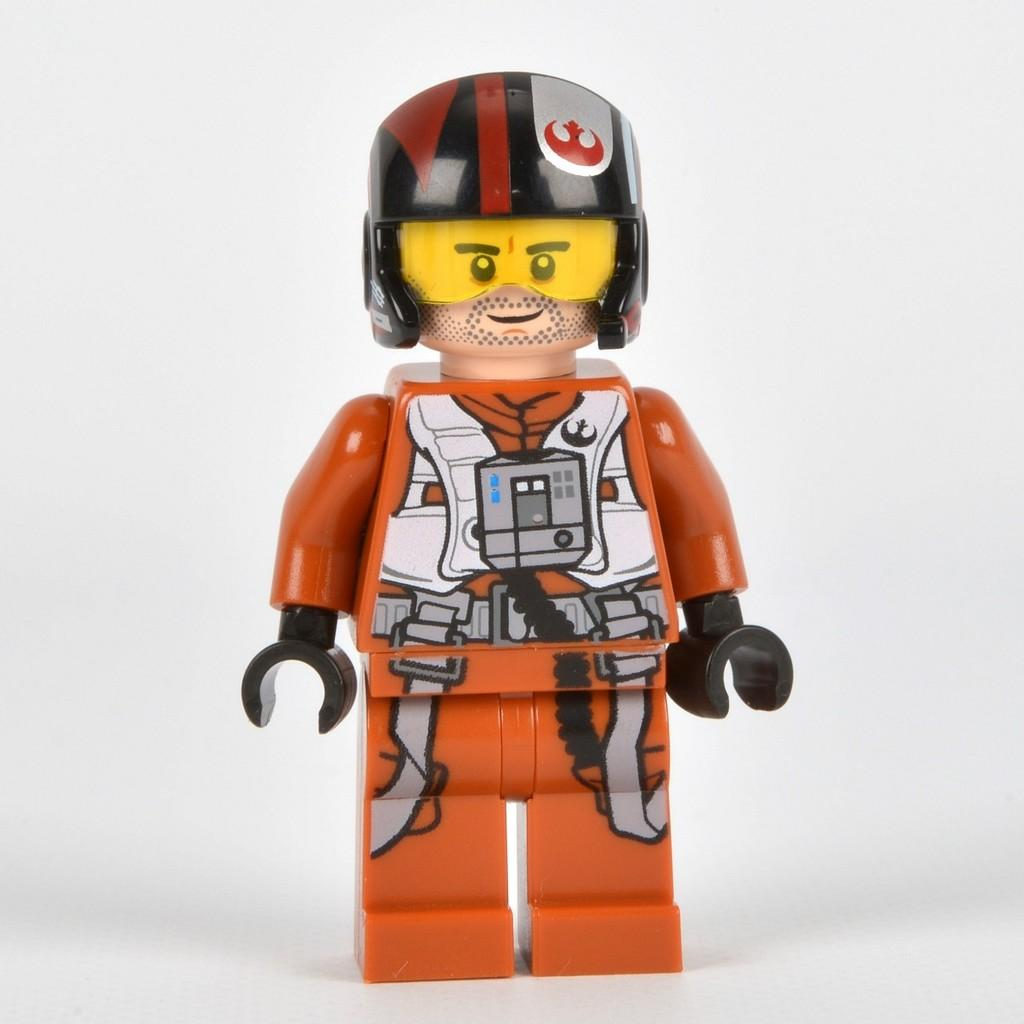What object is present in the image that resembles a toy? There is a toy in the image. On what surface is the toy placed? The toy is on a white surface. What color is the background of the image? The background of the image is white. Can you tell me how many times the toy coughs in the image? Toys do not have the ability to cough, so this action cannot be observed in the image. What type of sponge is being used to clean the toy in the image? There is no sponge present in the image, and the toy is not being cleaned. 